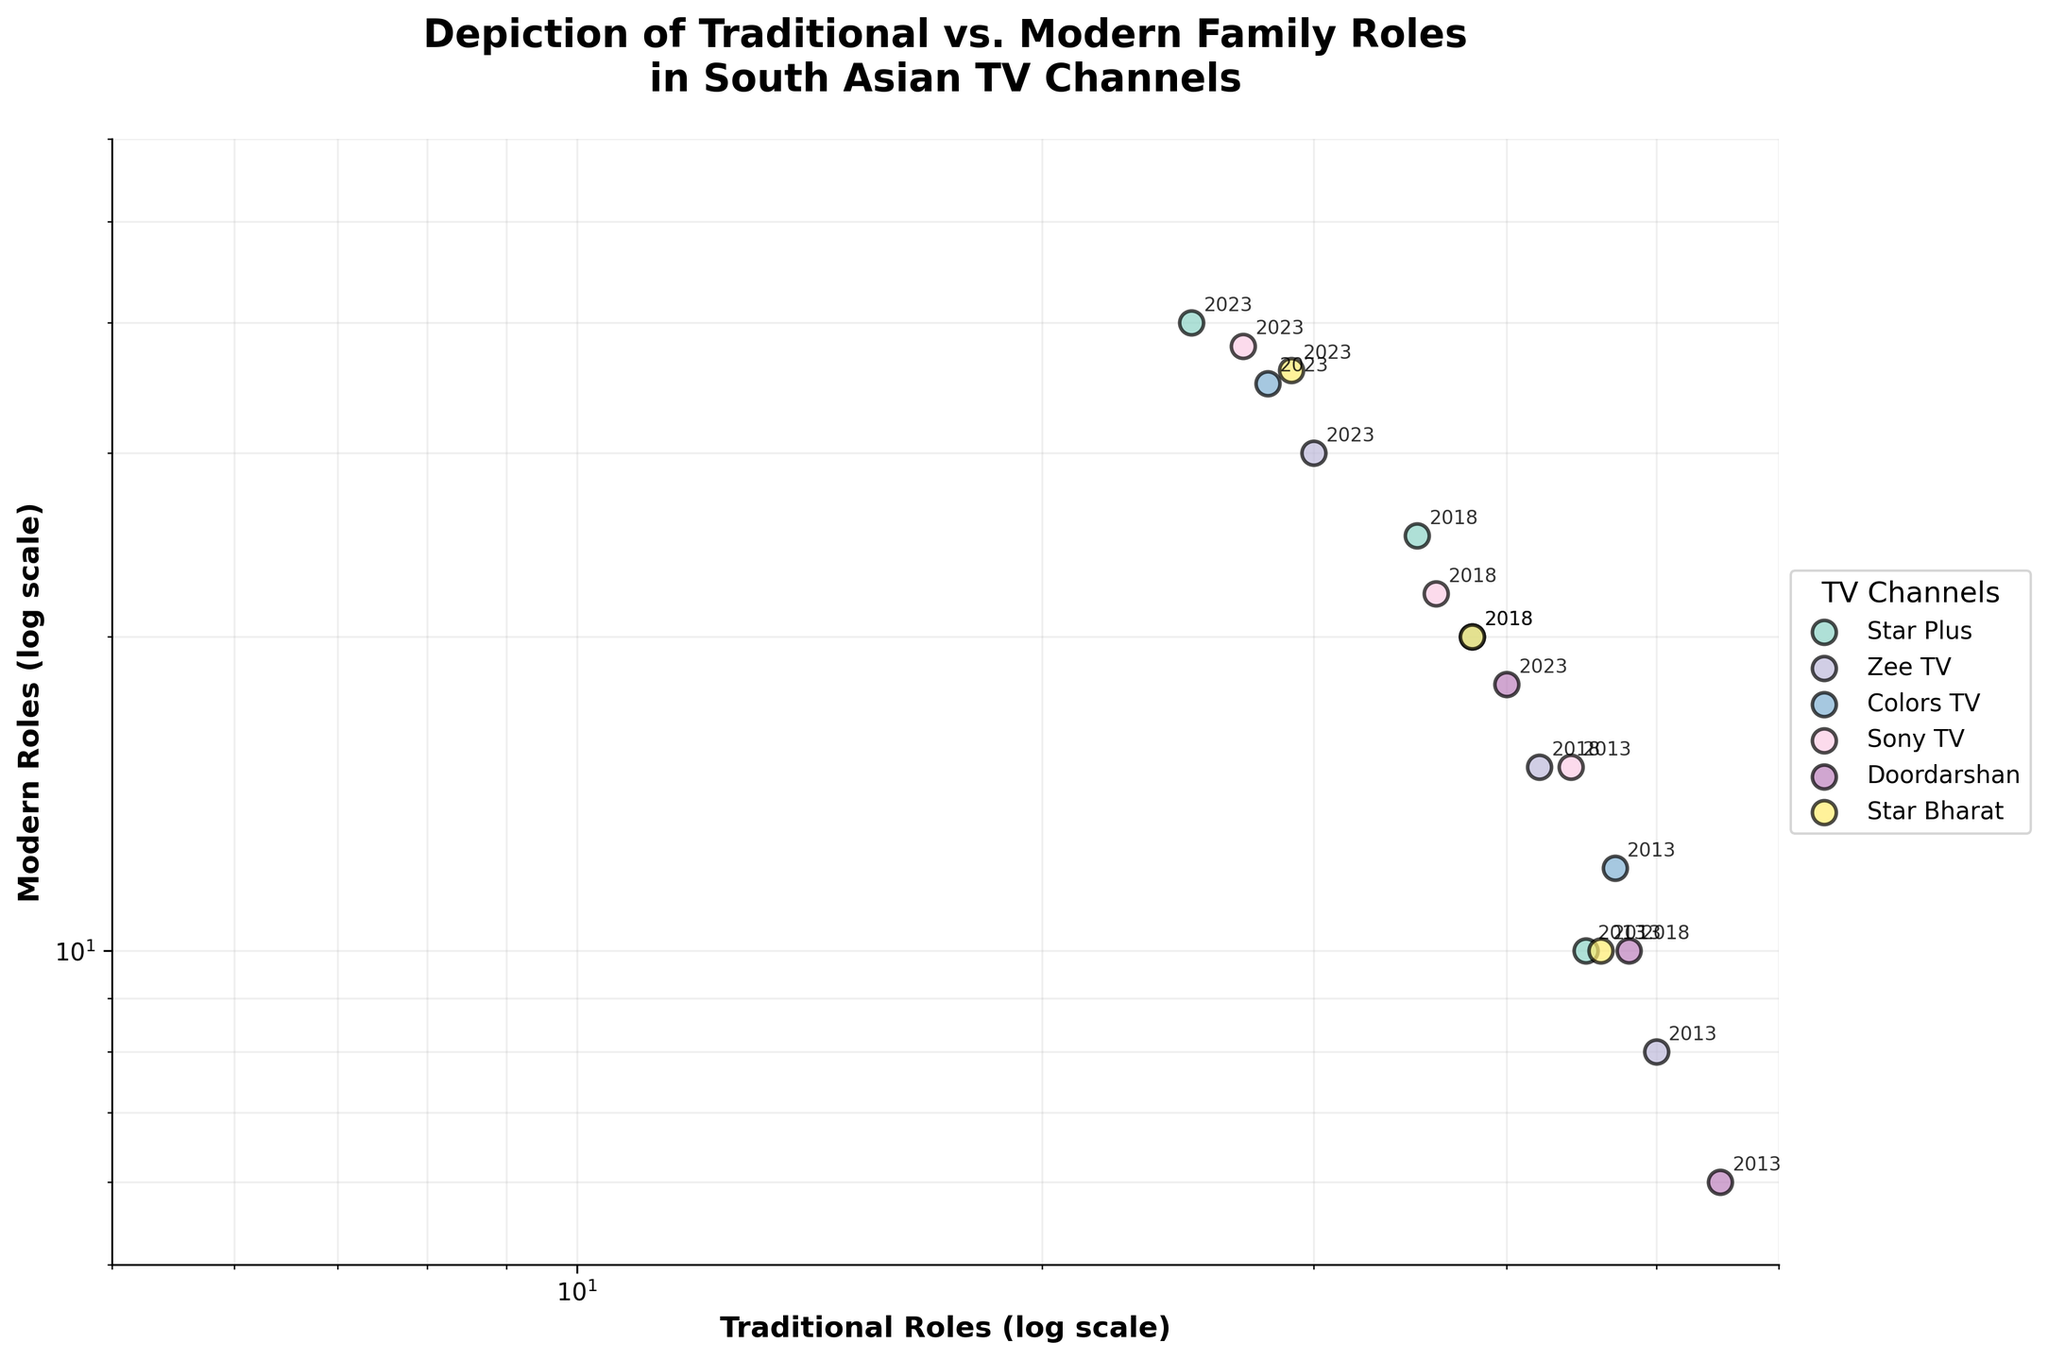What is the title of the figure? The title of the figure is located at the top of the plot. It reads "Depiction of Traditional vs. Modern Family Roles in South Asian TV Channels".
Answer: Depiction of Traditional vs. Modern Family Roles in South Asian TV Channels Which channel depicted the most traditional roles in 2013? For each channel, the year is annotated next to the corresponding data point. By checking the highest 'Traditional Roles' value in 2013, you can see that 'Doordarshan' has the most with 55.
Answer: Doordarshan How has the depiction of modern roles on Zee TV changed from 2013 to 2023? Look at the 'Modern Roles' values for Zee TV in 2013 and 2023. In 2013, it was 8, and in 2023, it's 30. The change is calculated as 30 - 8.
Answer: Increased by 22 Which channel showed the least traditional roles in 2023? Check the 'Traditional Roles' values for 2023 across all channels. Star Plus has the least with 25 traditional roles.
Answer: Star Plus Which year shows the highest number of modern roles across all channels? By comparing 'Modern Roles' for all channels, the highest value in the data across all years is 40 by Star Plus in 2023.
Answer: 2023 What is the trend in the depiction of traditional roles on Star Bharat over the years? By examining Star Bharat's data points in 2013, 2018, and 2023, you can see a decline from 46 to 38 to 29.
Answer: Decreasing How do the depiction frequencies of traditional roles on Star Plus and Colors TV compare in 2018? Compare the 'Traditional Roles' values for Star Plus and Colors TV in 2018. For Star Plus, it is 35, and for Colors TV, it is 38.
Answer: Colors TV has more What is the average number of traditional roles depicted by Doordarshan over the three years? Sum the 'Traditional Roles' values for 2013, 2018, and 2023 (55 + 48 + 40), and then divide by 3 to get the average.
Answer: 47.67 Which channel shows the most balanced depiction of traditional vs. modern roles in 2023? Balance can be interpreted as the smallest difference between the two values. For 2023, 'Traditional Roles' and 'Modern Roles' for each channel are closest for Sony TV (27 traditional and 38 modern roles). Calculate the difference for all channels and compare.
Answer: Sony TV 